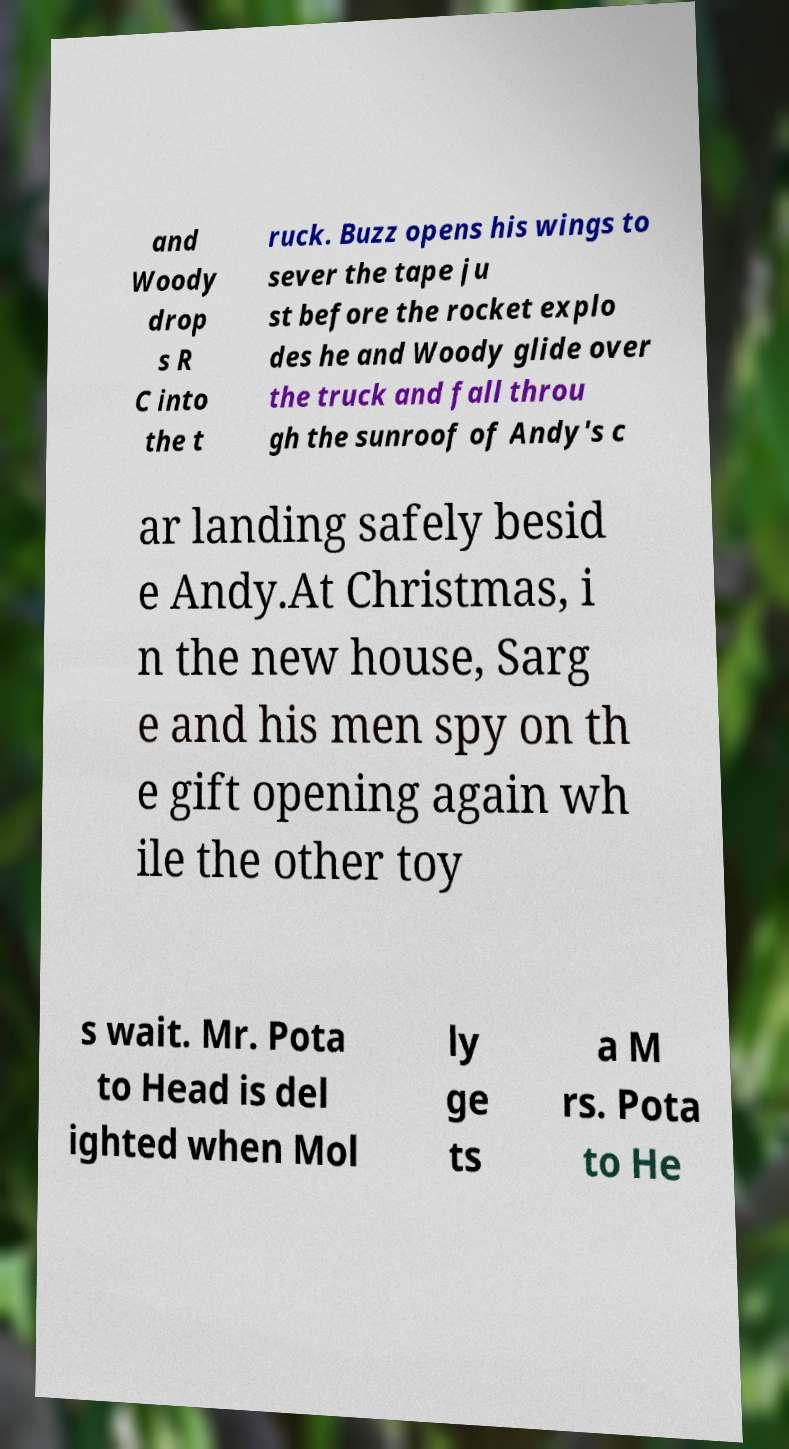Can you read and provide the text displayed in the image?This photo seems to have some interesting text. Can you extract and type it out for me? and Woody drop s R C into the t ruck. Buzz opens his wings to sever the tape ju st before the rocket explo des he and Woody glide over the truck and fall throu gh the sunroof of Andy's c ar landing safely besid e Andy.At Christmas, i n the new house, Sarg e and his men spy on th e gift opening again wh ile the other toy s wait. Mr. Pota to Head is del ighted when Mol ly ge ts a M rs. Pota to He 